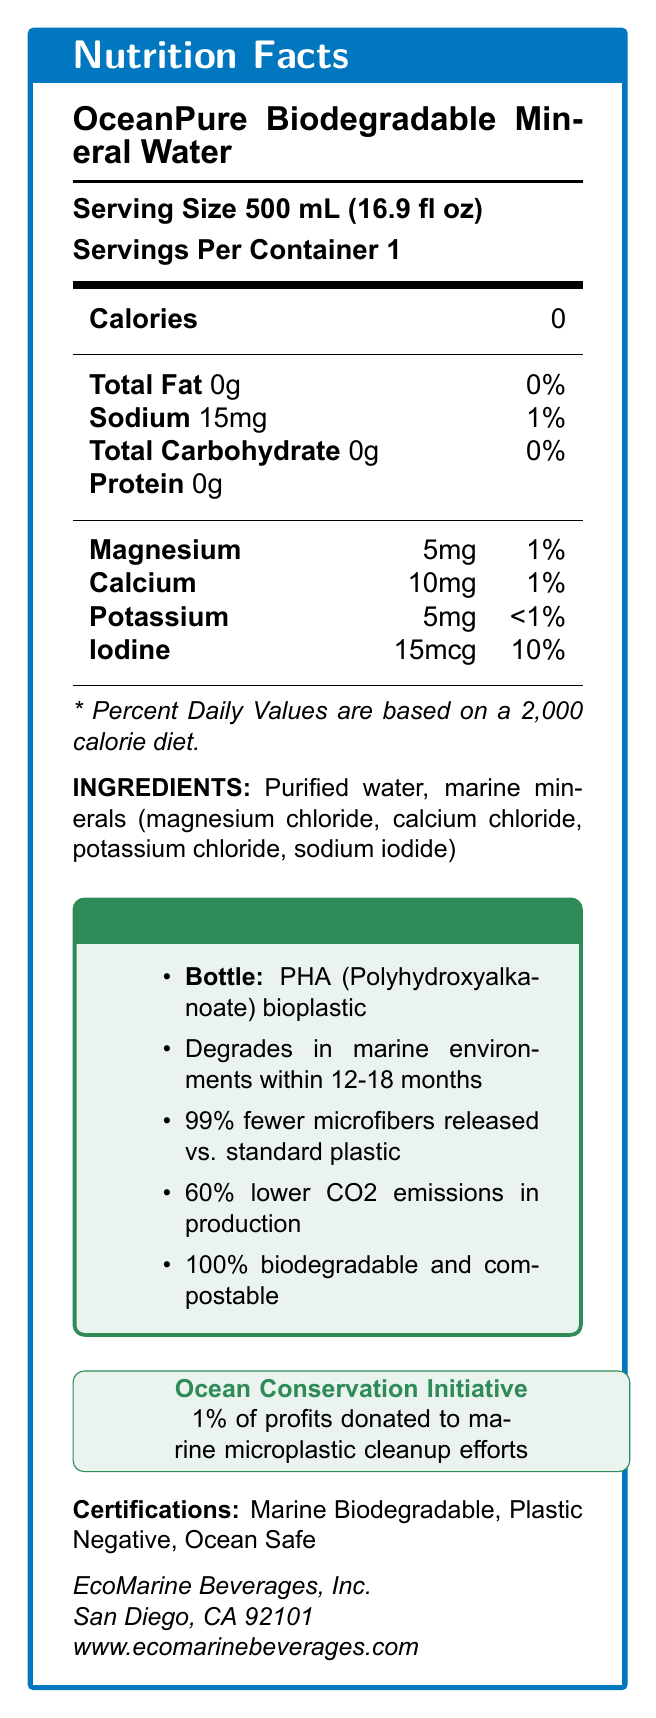who is the manufacturer of OceanPure Biodegradable Mineral Water? The manufacturer information is stated at the bottom of the document.
Answer: EcoMarine Beverages, Inc. what is the serving size of OceanPure Biodegradable Mineral Water? The serving size is listed under the "Nutrition Facts" section.
Answer: 500 mL (16.9 fl oz) how much sodium does one serving of OceanPure Biodegradable Mineral Water contain? The sodium content per serving is listed in the nutritional information in the document.
Answer: 15mg what is the primary material of the bottle? The primary material of the bottle is listed under the "Eco-Friendly Features" section.
Answer: PHA (Polyhydroxyalkanoate) bioplastic how long does the bottle take to degrade in marine environments? The biodegradability information is stated under the "Eco-Friendly Features" section.
Answer: 12-18 months what percentage of daily iodine is provided by one serving? The daily value percentage for iodine is listed under the minerals section in the nutritional information.
Answer: 10% list the marine minerals included in OceanPure Biodegradable Mineral Water. These minerals are listed under the "minerals" section in the nutritional information.
Answer: Magnesium, Calcium, Potassium, Iodine what certifications does OceanPure Biodegradable Mineral Water have? The certifications are listed toward the bottom of the document.
Answer: Marine Biodegradable, Plastic Negative, Ocean Safe what is the carbon footprint reduction in production compared to conventional plastic bottles? The carbon footprint reduction information is listed under the "Eco-Friendly Features" section.
Answer: 60% lower CO2 emissions what percentage of profits is donated to marine microplastic cleanup efforts? This information is stated under the "Ocean Conservation Initiative" section.
Answer: 1% what is the total fat content per serving? The total fat content per serving is listed in the nutritional information.
Answer: 0g what minerals contribute to the daily value percentage? A. Magnesium B. Calcium C. Potassium D. Iodine While other minerals like Magnesium and Calcium also have daily values, Iodine has the highest with 10%.
Answer: D. Iodine what is the address of the manufacturer? A. Los Angeles, CA B. San Diego, CA C. San Francisco, CA D. New York, NY The manufacturer's location is San Diego, CA, as listed at the bottom of the document.
Answer: B. San Diego, CA does the bottle release more microfibers compared to standard plastic bottles? The document states that the bottle releases 99% fewer microfibers compared to standard plastic bottles.
Answer: No summarize the main eco-friendly features of the OceanPure Biodegradable Mineral Water bottle. These features are listed under the "Eco-Friendly Features" section in the document.
Answer: The OceanPure Biodegradable Mineral Water bottle is made from PHA bioplastic, degrades in marine environments within 12-18 months, releases 99% fewer microfibers compared to standard plastic bottles, has 60% lower CO2 emissions in production, and is 100% biodegradable and compostable. what year was the manufacturer established? The document does not provide information about the year the manufacturer was established.
Answer: Not enough information describe the main purpose of the OceanPure Biodegradable Mineral Water product. The entire document focuses on the nutritional aspects as well as the eco-friendly features of the product.
Answer: The OceanPure Biodegradable Mineral Water product aims to provide mineral-enriched water while being environmentally friendly. The bottle is made from PHA bioplastic, which degrades in marine environments within 12-18 months, releases significantly fewer microfibers compared to standard plastic bottles, reduces carbon footprint, and is compostable. The product also supports marine microplastic cleanup efforts by donating 1% of profits to these initiatives. 